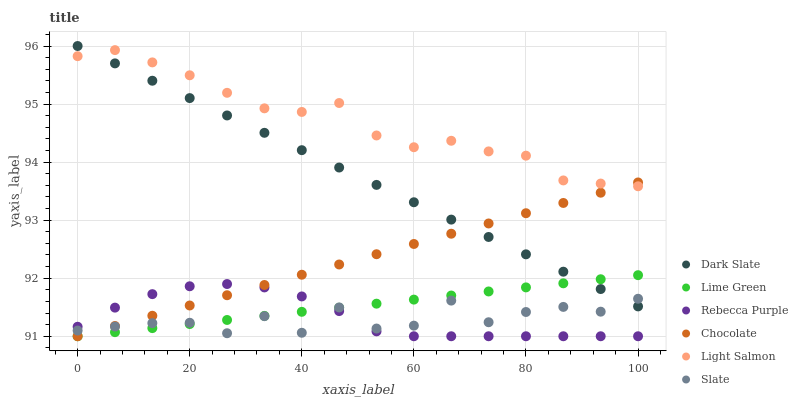Does Slate have the minimum area under the curve?
Answer yes or no. Yes. Does Light Salmon have the maximum area under the curve?
Answer yes or no. Yes. Does Chocolate have the minimum area under the curve?
Answer yes or no. No. Does Chocolate have the maximum area under the curve?
Answer yes or no. No. Is Chocolate the smoothest?
Answer yes or no. Yes. Is Slate the roughest?
Answer yes or no. Yes. Is Slate the smoothest?
Answer yes or no. No. Is Chocolate the roughest?
Answer yes or no. No. Does Chocolate have the lowest value?
Answer yes or no. Yes. Does Slate have the lowest value?
Answer yes or no. No. Does Dark Slate have the highest value?
Answer yes or no. Yes. Does Chocolate have the highest value?
Answer yes or no. No. Is Lime Green less than Light Salmon?
Answer yes or no. Yes. Is Light Salmon greater than Slate?
Answer yes or no. Yes. Does Chocolate intersect Dark Slate?
Answer yes or no. Yes. Is Chocolate less than Dark Slate?
Answer yes or no. No. Is Chocolate greater than Dark Slate?
Answer yes or no. No. Does Lime Green intersect Light Salmon?
Answer yes or no. No. 